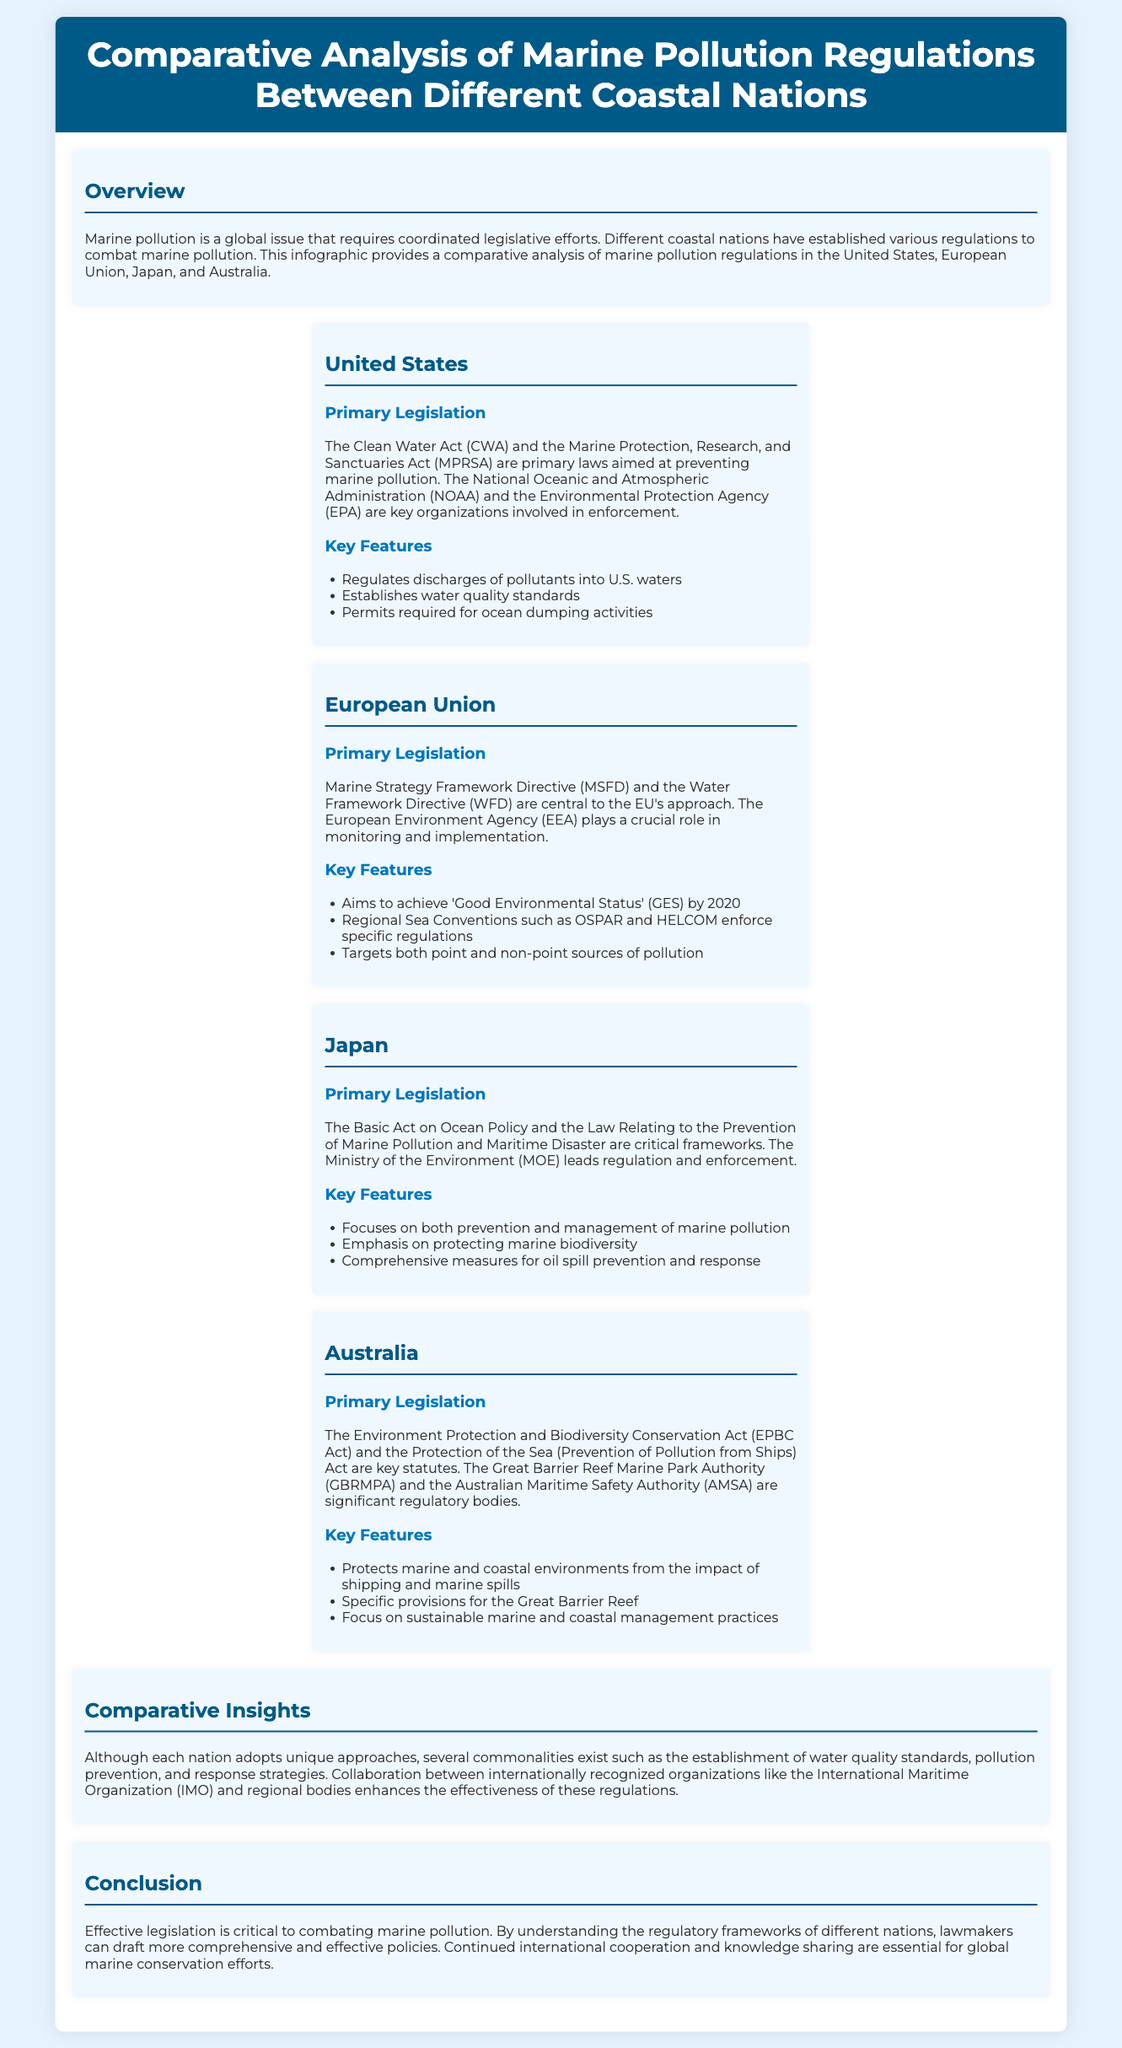What are the primary laws in the United States related to marine pollution? The document states that the Clean Water Act (CWA) and the Marine Protection, Research, and Sanctuaries Act (MPRSA) are the primary laws in the United States.
Answer: Clean Water Act and Marine Protection, Research, and Sanctuaries Act What does the European Union aim to achieve by 2020? According to the document, the European Union aims to achieve 'Good Environmental Status' (GES) by 2020.
Answer: Good Environmental Status (GES) Which organization is responsible for monitoring in the European Union? The document indicates that the European Environment Agency (EEA) plays a crucial role in monitoring and implementation in the European Union.
Answer: European Environment Agency (EEA) What is a key focus of Japan's marine pollution legislation? The document highlights that Japan's legislation focuses on both prevention and management of marine pollution.
Answer: Prevention and management of marine pollution What are the key regulatory bodies in Australia for marine pollution? The document mentions that the Great Barrier Reef Marine Park Authority (GBRMPA) and the Australian Maritime Safety Authority (AMSA) are significant regulatory bodies in Australia.
Answer: GBRMPA and AMSA How many coastal nations are discussed in the document? The document provides a comparative analysis of marine pollution regulations in four coastal nations.
Answer: Four What is a common theme among the regulations of different nations? The document notes that a common theme includes the establishment of water quality standards.
Answer: Establishment of water quality standards What does the term "pollution prevention" refer to in the context of this document? The document identifies pollution prevention as one of the commonalities in the marine pollution regulations across different nations.
Answer: Pollution prevention Which legislation in Australia protects the Great Barrier Reef? The document states that the Environment Protection and Biodiversity Conservation Act (EPBC Act) contains specific provisions for the Great Barrier Reef.
Answer: EPBC Act 